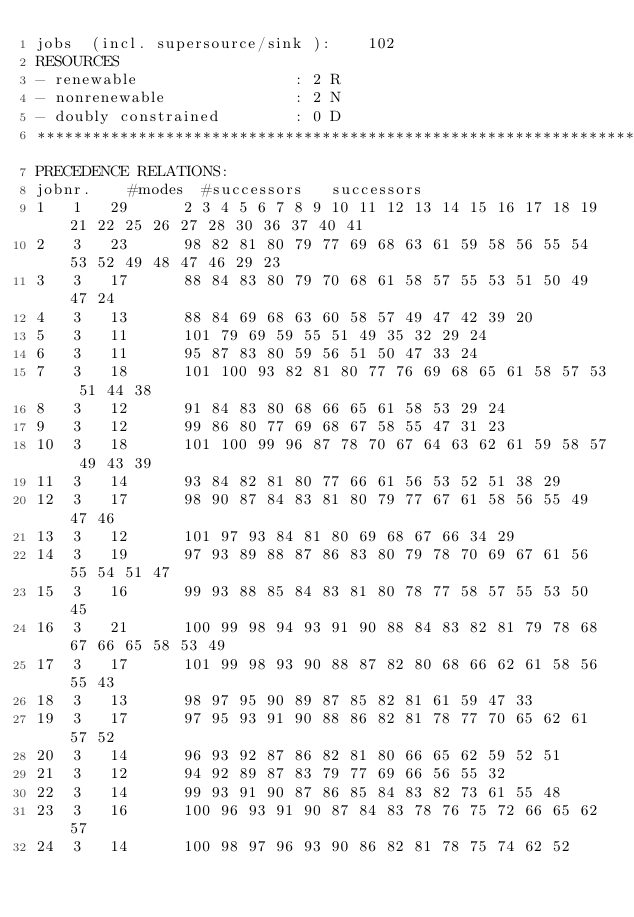<code> <loc_0><loc_0><loc_500><loc_500><_ObjectiveC_>jobs  (incl. supersource/sink ):	102
RESOURCES
- renewable                 : 2 R
- nonrenewable              : 2 N
- doubly constrained        : 0 D
************************************************************************
PRECEDENCE RELATIONS:
jobnr.    #modes  #successors   successors
1	1	29		2 3 4 5 6 7 8 9 10 11 12 13 14 15 16 17 18 19 21 22 25 26 27 28 30 36 37 40 41 
2	3	23		98 82 81 80 79 77 69 68 63 61 59 58 56 55 54 53 52 49 48 47 46 29 23 
3	3	17		88 84 83 80 79 70 68 61 58 57 55 53 51 50 49 47 24 
4	3	13		88 84 69 68 63 60 58 57 49 47 42 39 20 
5	3	11		101 79 69 59 55 51 49 35 32 29 24 
6	3	11		95 87 83 80 59 56 51 50 47 33 24 
7	3	18		101 100 93 82 81 80 77 76 69 68 65 61 58 57 53 51 44 38 
8	3	12		91 84 83 80 68 66 65 61 58 53 29 24 
9	3	12		99 86 80 77 69 68 67 58 55 47 31 23 
10	3	18		101 100 99 96 87 78 70 67 64 63 62 61 59 58 57 49 43 39 
11	3	14		93 84 82 81 80 77 66 61 56 53 52 51 38 29 
12	3	17		98 90 87 84 83 81 80 79 77 67 61 58 56 55 49 47 46 
13	3	12		101 97 93 84 81 80 69 68 67 66 34 29 
14	3	19		97 93 89 88 87 86 83 80 79 78 70 69 67 61 56 55 54 51 47 
15	3	16		99 93 88 85 84 83 81 80 78 77 58 57 55 53 50 45 
16	3	21		100 99 98 94 93 91 90 88 84 83 82 81 79 78 68 67 66 65 58 53 49 
17	3	17		101 99 98 93 90 88 87 82 80 68 66 62 61 58 56 55 43 
18	3	13		98 97 95 90 89 87 85 82 81 61 59 47 33 
19	3	17		97 95 93 91 90 88 86 82 81 78 77 70 65 62 61 57 52 
20	3	14		96 93 92 87 86 82 81 80 66 65 62 59 52 51 
21	3	12		94 92 89 87 83 79 77 69 66 56 55 32 
22	3	14		99 93 91 90 87 86 85 84 83 82 73 61 55 48 
23	3	16		100 96 93 91 90 87 84 83 78 76 75 72 66 65 62 57 
24	3	14		100 98 97 96 93 90 86 82 81 78 75 74 62 52 </code> 